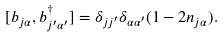Convert formula to latex. <formula><loc_0><loc_0><loc_500><loc_500>[ b _ { j \alpha } , b _ { j ^ { \prime } \alpha ^ { \prime } } ^ { \dagger } ] = \delta _ { j j ^ { \prime } } \delta _ { \alpha \alpha ^ { \prime } } ( 1 - 2 n _ { j \alpha } ) .</formula> 